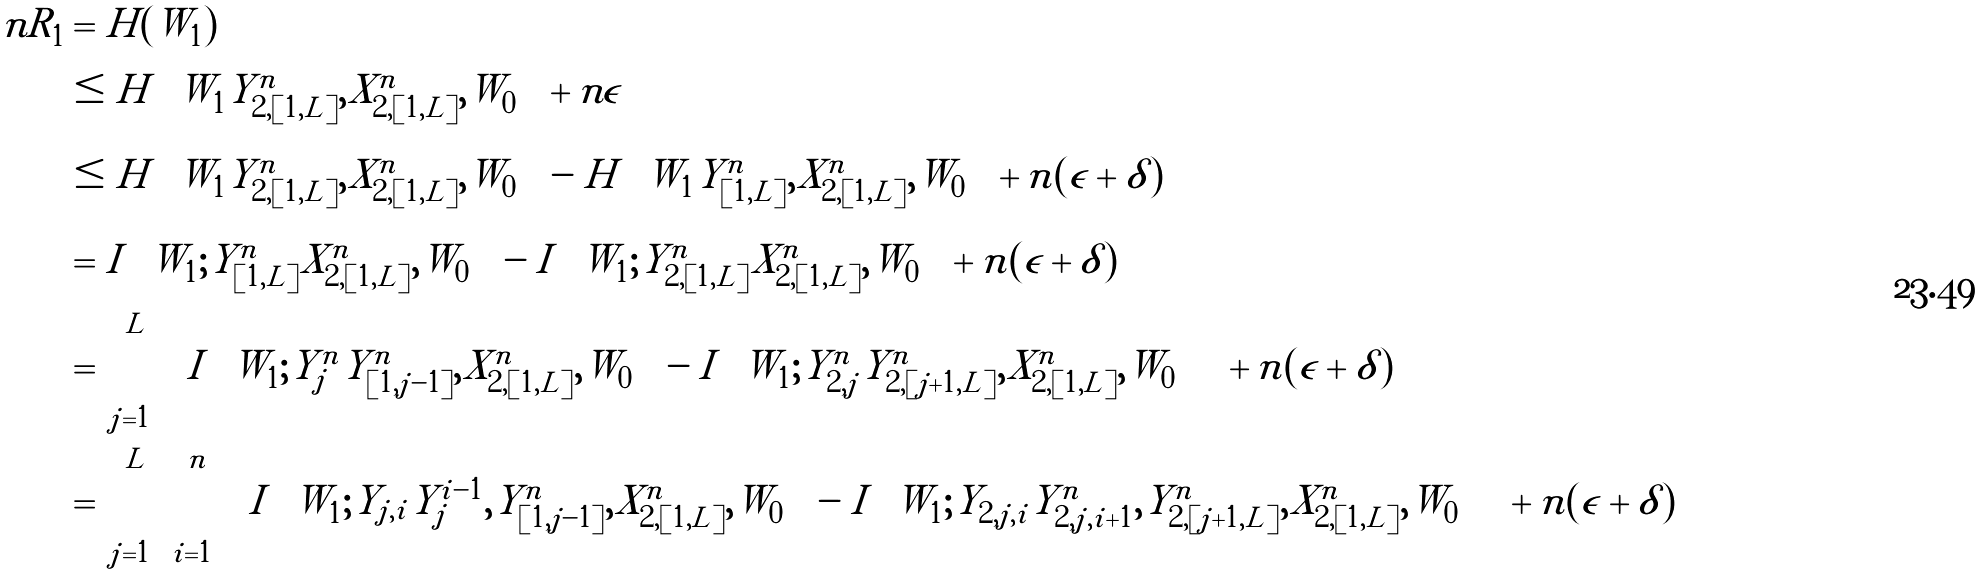Convert formula to latex. <formula><loc_0><loc_0><loc_500><loc_500>n R _ { 1 } & = H ( W _ { 1 } ) \\ & \leq H \left ( W _ { 1 } | Y ^ { n } _ { 2 , [ 1 , L ] } , X ^ { n } _ { 2 , [ 1 , L ] } , W _ { 0 } \right ) + n \epsilon \\ & \leq H \left ( W _ { 1 } | Y ^ { n } _ { 2 , [ 1 , L ] } , X ^ { n } _ { 2 , [ 1 , L ] } , W _ { 0 } \right ) - H \left ( W _ { 1 } | Y ^ { n } _ { [ 1 , L ] } , X ^ { n } _ { 2 , [ 1 , L ] } , W _ { 0 } \right ) + n ( \epsilon + \delta ) \\ & = I \left ( W _ { 1 } ; Y ^ { n } _ { [ 1 , L ] } | X ^ { n } _ { 2 , [ 1 , L ] } , W _ { 0 } \right ) - I \left ( W _ { 1 } ; Y ^ { n } _ { 2 , [ 1 , L ] } | X ^ { n } _ { 2 , [ 1 , L ] } , W _ { 0 } \right ) + n ( \epsilon + \delta ) \\ & = \sum _ { j = 1 } ^ { L } \left [ I \left ( W _ { 1 } ; Y ^ { n } _ { j } | Y ^ { n } _ { [ 1 , j - 1 ] } , X ^ { n } _ { 2 , [ 1 , L ] } , W _ { 0 } \right ) - I \left ( W _ { 1 } ; Y ^ { n } _ { 2 , j } | Y ^ { n } _ { 2 , [ j + 1 , L ] } , X ^ { n } _ { 2 , [ 1 , L ] } , W _ { 0 } \right ) \right ] + n ( \epsilon + \delta ) \\ & = \sum _ { j = 1 } ^ { L } \sum _ { i = 1 } ^ { n } \left [ I \left ( W _ { 1 } ; Y _ { j , i } | Y _ { j } ^ { i - 1 } , Y ^ { n } _ { [ 1 , j - 1 ] } , X ^ { n } _ { 2 , [ 1 , L ] } , W _ { 0 } \right ) - I \left ( W _ { 1 } ; Y _ { 2 , j , i } | Y ^ { n } _ { 2 , j , i + 1 } , Y ^ { n } _ { 2 , [ j + 1 , L ] } , X ^ { n } _ { 2 , [ 1 , L ] } , W _ { 0 } \right ) \right ] + n ( \epsilon + \delta )</formula> 